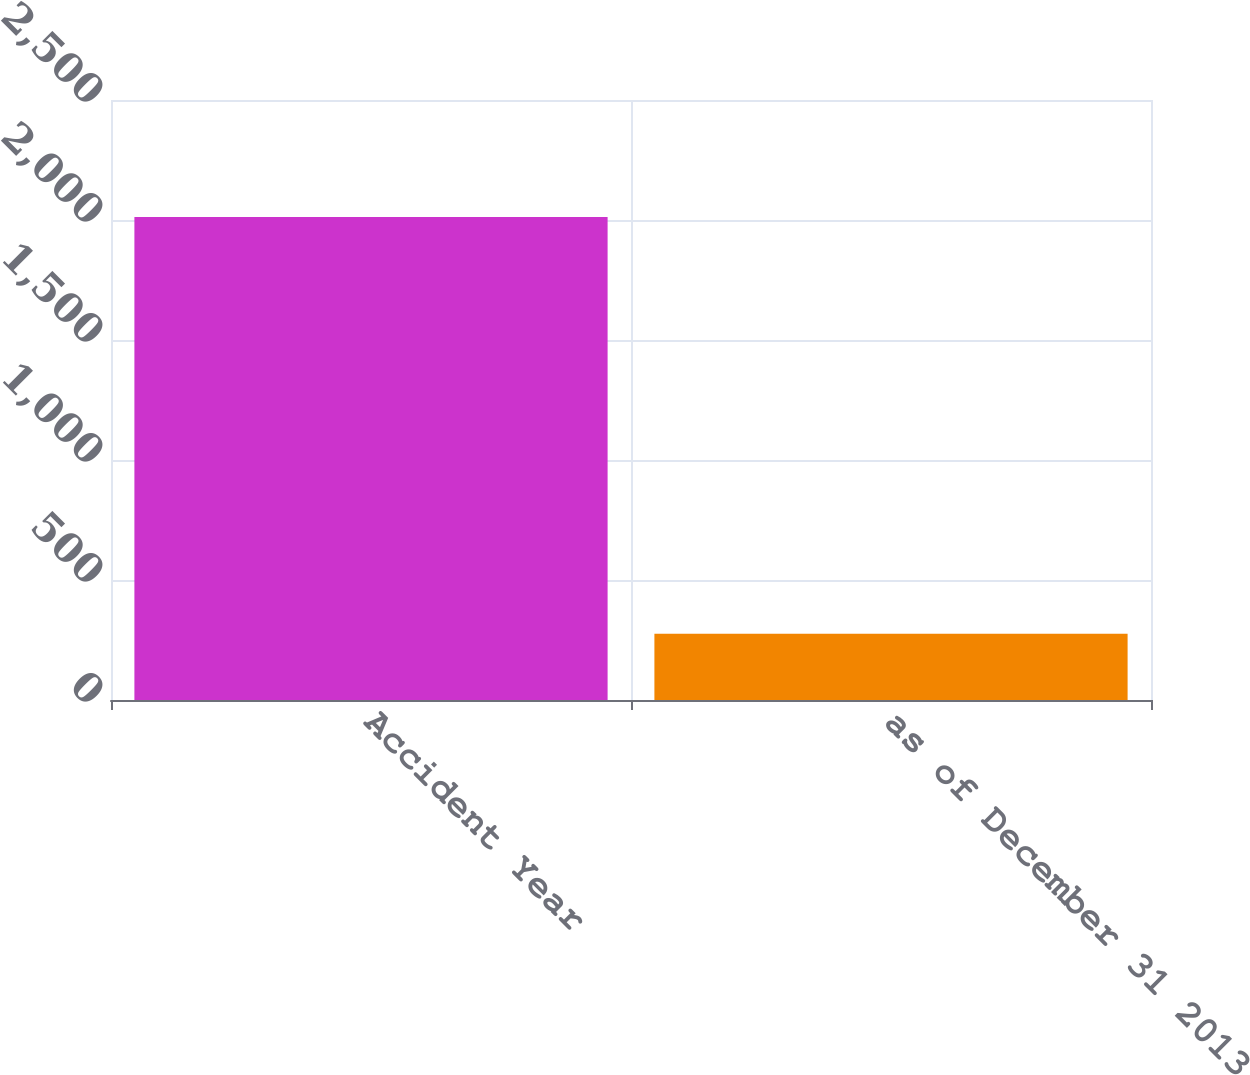<chart> <loc_0><loc_0><loc_500><loc_500><bar_chart><fcel>Accident Year<fcel>as of December 31 2013<nl><fcel>2013<fcel>276<nl></chart> 